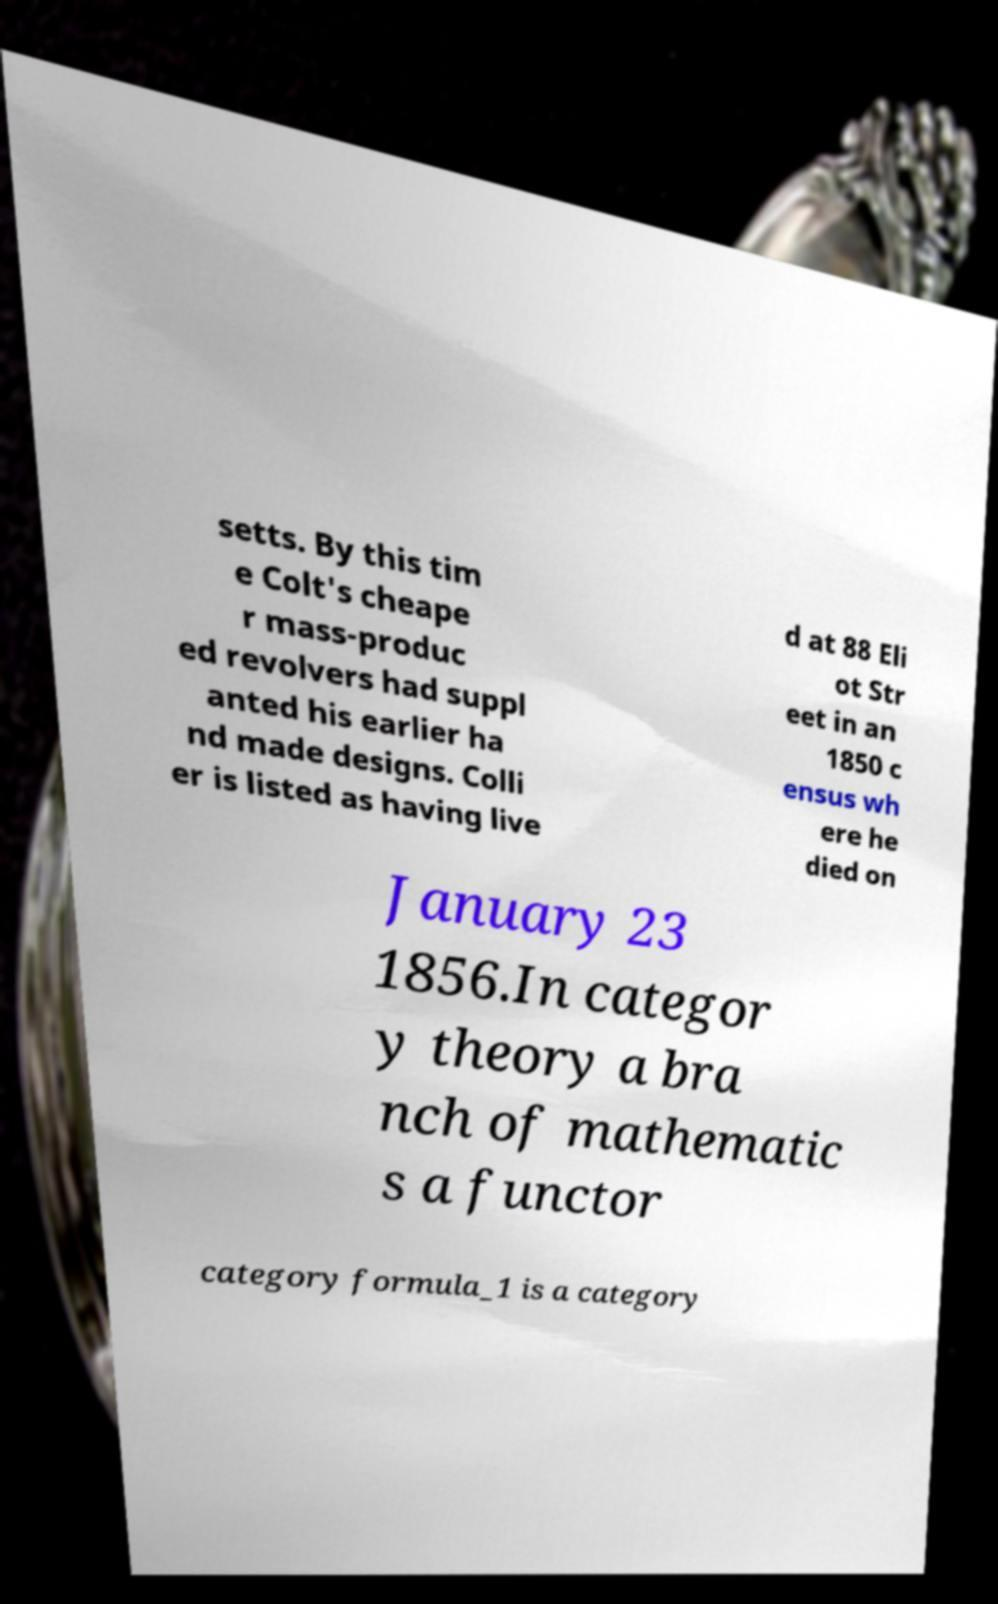I need the written content from this picture converted into text. Can you do that? setts. By this tim e Colt's cheape r mass-produc ed revolvers had suppl anted his earlier ha nd made designs. Colli er is listed as having live d at 88 Eli ot Str eet in an 1850 c ensus wh ere he died on January 23 1856.In categor y theory a bra nch of mathematic s a functor category formula_1 is a category 